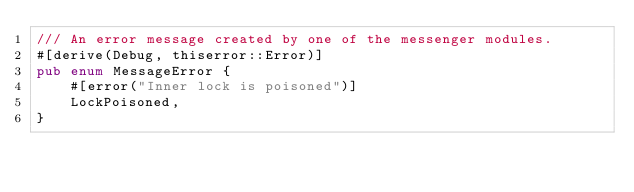Convert code to text. <code><loc_0><loc_0><loc_500><loc_500><_Rust_>/// An error message created by one of the messenger modules.
#[derive(Debug, thiserror::Error)]
pub enum MessageError {
    #[error("Inner lock is poisoned")]
    LockPoisoned,
}
</code> 